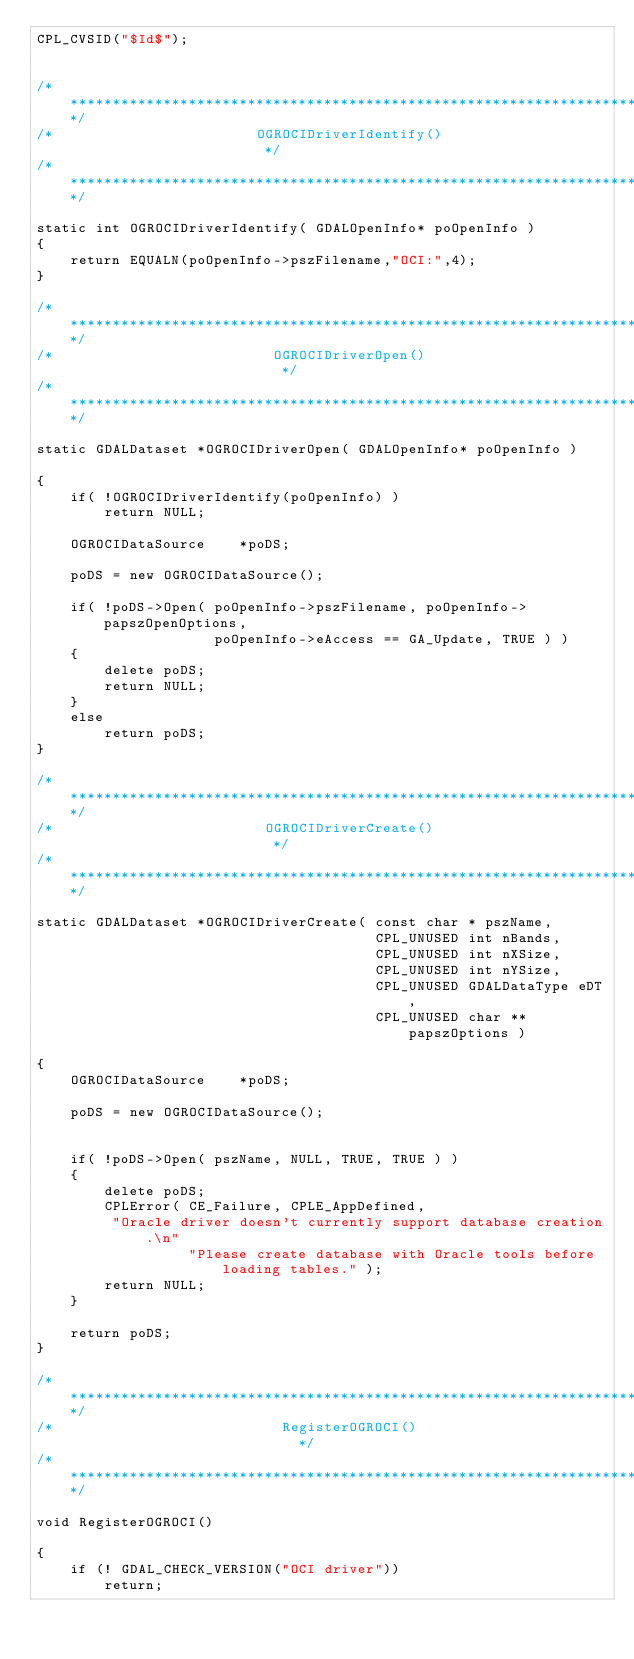Convert code to text. <code><loc_0><loc_0><loc_500><loc_500><_C++_>CPL_CVSID("$Id$");


/************************************************************************/
/*                        OGROCIDriverIdentify()                        */
/************************************************************************/

static int OGROCIDriverIdentify( GDALOpenInfo* poOpenInfo )
{
    return EQUALN(poOpenInfo->pszFilename,"OCI:",4);
}

/************************************************************************/
/*                          OGROCIDriverOpen()                          */
/************************************************************************/

static GDALDataset *OGROCIDriverOpen( GDALOpenInfo* poOpenInfo )

{
    if( !OGROCIDriverIdentify(poOpenInfo) )
        return NULL;

    OGROCIDataSource    *poDS;

    poDS = new OGROCIDataSource();

    if( !poDS->Open( poOpenInfo->pszFilename, poOpenInfo->papszOpenOptions,
                     poOpenInfo->eAccess == GA_Update, TRUE ) )
    {
        delete poDS;
        return NULL;
    }
    else
        return poDS;
}

/************************************************************************/
/*                         OGROCIDriverCreate()                         */
/************************************************************************/

static GDALDataset *OGROCIDriverCreate( const char * pszName,
                                        CPL_UNUSED int nBands,
                                        CPL_UNUSED int nXSize,
                                        CPL_UNUSED int nYSize,
                                        CPL_UNUSED GDALDataType eDT,
                                        CPL_UNUSED char **papszOptions )

{
    OGROCIDataSource    *poDS;

    poDS = new OGROCIDataSource();


    if( !poDS->Open( pszName, NULL, TRUE, TRUE ) )
    {
        delete poDS;
        CPLError( CE_Failure, CPLE_AppDefined, 
         "Oracle driver doesn't currently support database creation.\n"
                  "Please create database with Oracle tools before loading tables." );
        return NULL;
    }

    return poDS;
}

/************************************************************************/
/*                           RegisterOGROCI()                            */
/************************************************************************/

void RegisterOGROCI()

{
    if (! GDAL_CHECK_VERSION("OCI driver"))
        return;
    </code> 